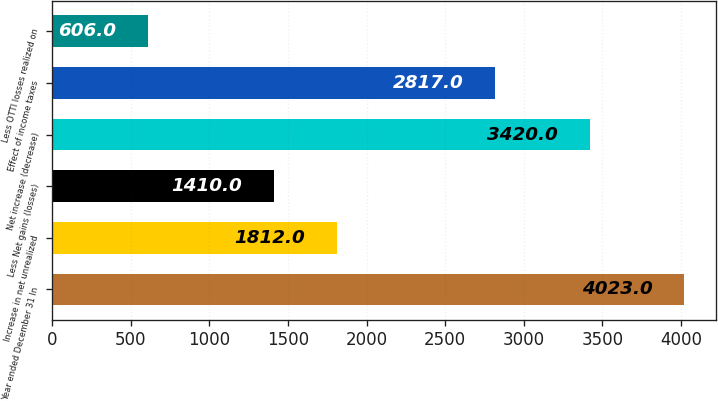<chart> <loc_0><loc_0><loc_500><loc_500><bar_chart><fcel>Year ended December 31 In<fcel>Increase in net unrealized<fcel>Less Net gains (losses)<fcel>Net increase (decrease)<fcel>Effect of income taxes<fcel>Less OTTI losses realized on<nl><fcel>4023<fcel>1812<fcel>1410<fcel>3420<fcel>2817<fcel>606<nl></chart> 